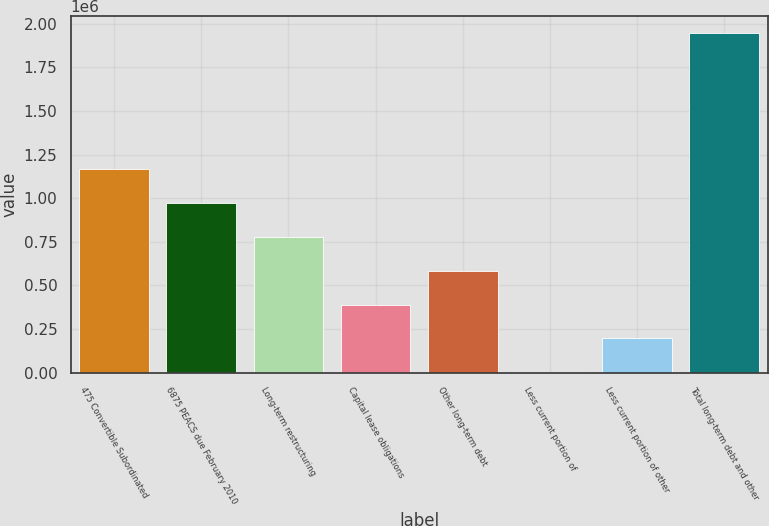Convert chart. <chart><loc_0><loc_0><loc_500><loc_500><bar_chart><fcel>475 Convertible Subordinated<fcel>6875 PEACS due February 2010<fcel>Long-term restructuring<fcel>Capital lease obligations<fcel>Other long-term debt<fcel>Less current portion of<fcel>Less current portion of other<fcel>Total long-term debt and other<nl><fcel>1.16789e+06<fcel>973498<fcel>779110<fcel>390334<fcel>584722<fcel>1558<fcel>195946<fcel>1.94544e+06<nl></chart> 